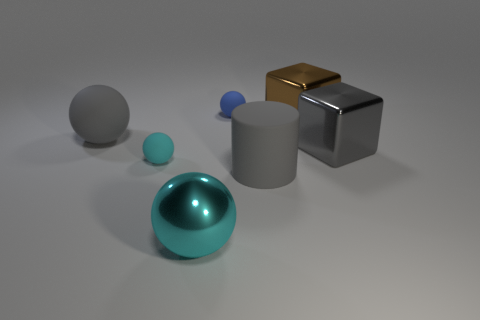There is a brown object that is to the right of the blue rubber thing; how many brown blocks are right of it? In the image, there is one brown block to the right of the blue spherical object. It has a shiny, metallic finish and sits on the far right, displaying clear, sharp edges that contrast with the other objects' various shapes and materials. 